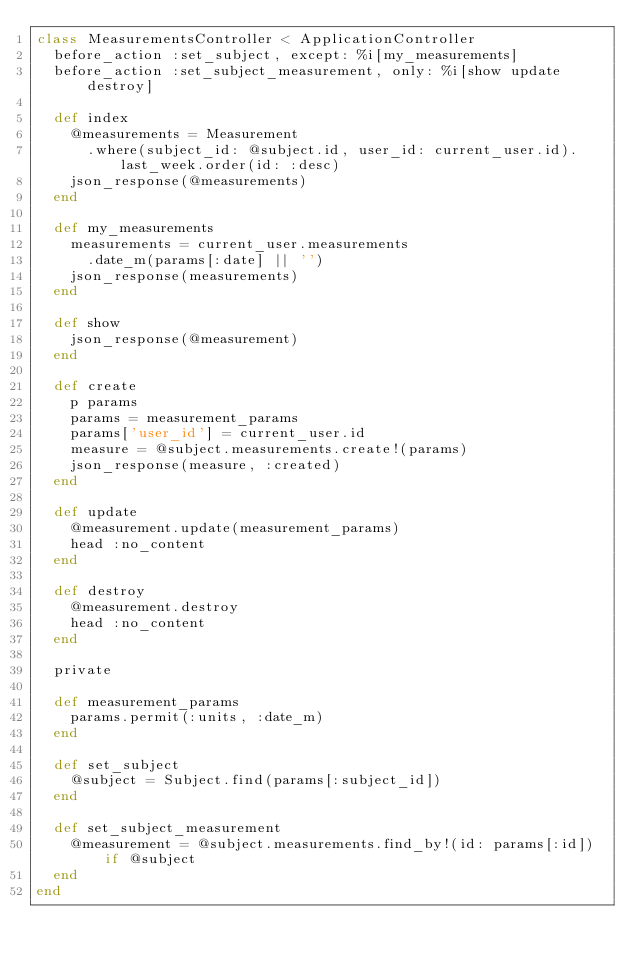<code> <loc_0><loc_0><loc_500><loc_500><_Ruby_>class MeasurementsController < ApplicationController
  before_action :set_subject, except: %i[my_measurements]
  before_action :set_subject_measurement, only: %i[show update destroy]

  def index
    @measurements = Measurement
      .where(subject_id: @subject.id, user_id: current_user.id).last_week.order(id: :desc)
    json_response(@measurements)
  end

  def my_measurements
    measurements = current_user.measurements
      .date_m(params[:date] || '')
    json_response(measurements)
  end

  def show
    json_response(@measurement)
  end

  def create
    p params
    params = measurement_params
    params['user_id'] = current_user.id
    measure = @subject.measurements.create!(params)
    json_response(measure, :created)
  end

  def update
    @measurement.update(measurement_params)
    head :no_content
  end

  def destroy
    @measurement.destroy
    head :no_content
  end

  private

  def measurement_params
    params.permit(:units, :date_m)
  end

  def set_subject
    @subject = Subject.find(params[:subject_id])
  end

  def set_subject_measurement
    @measurement = @subject.measurements.find_by!(id: params[:id]) if @subject
  end
end
</code> 